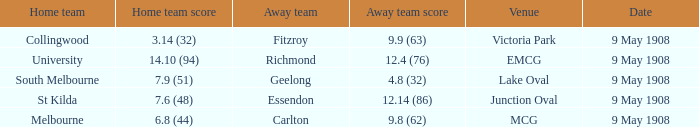Name the home team score for south melbourne home team 7.9 (51). 